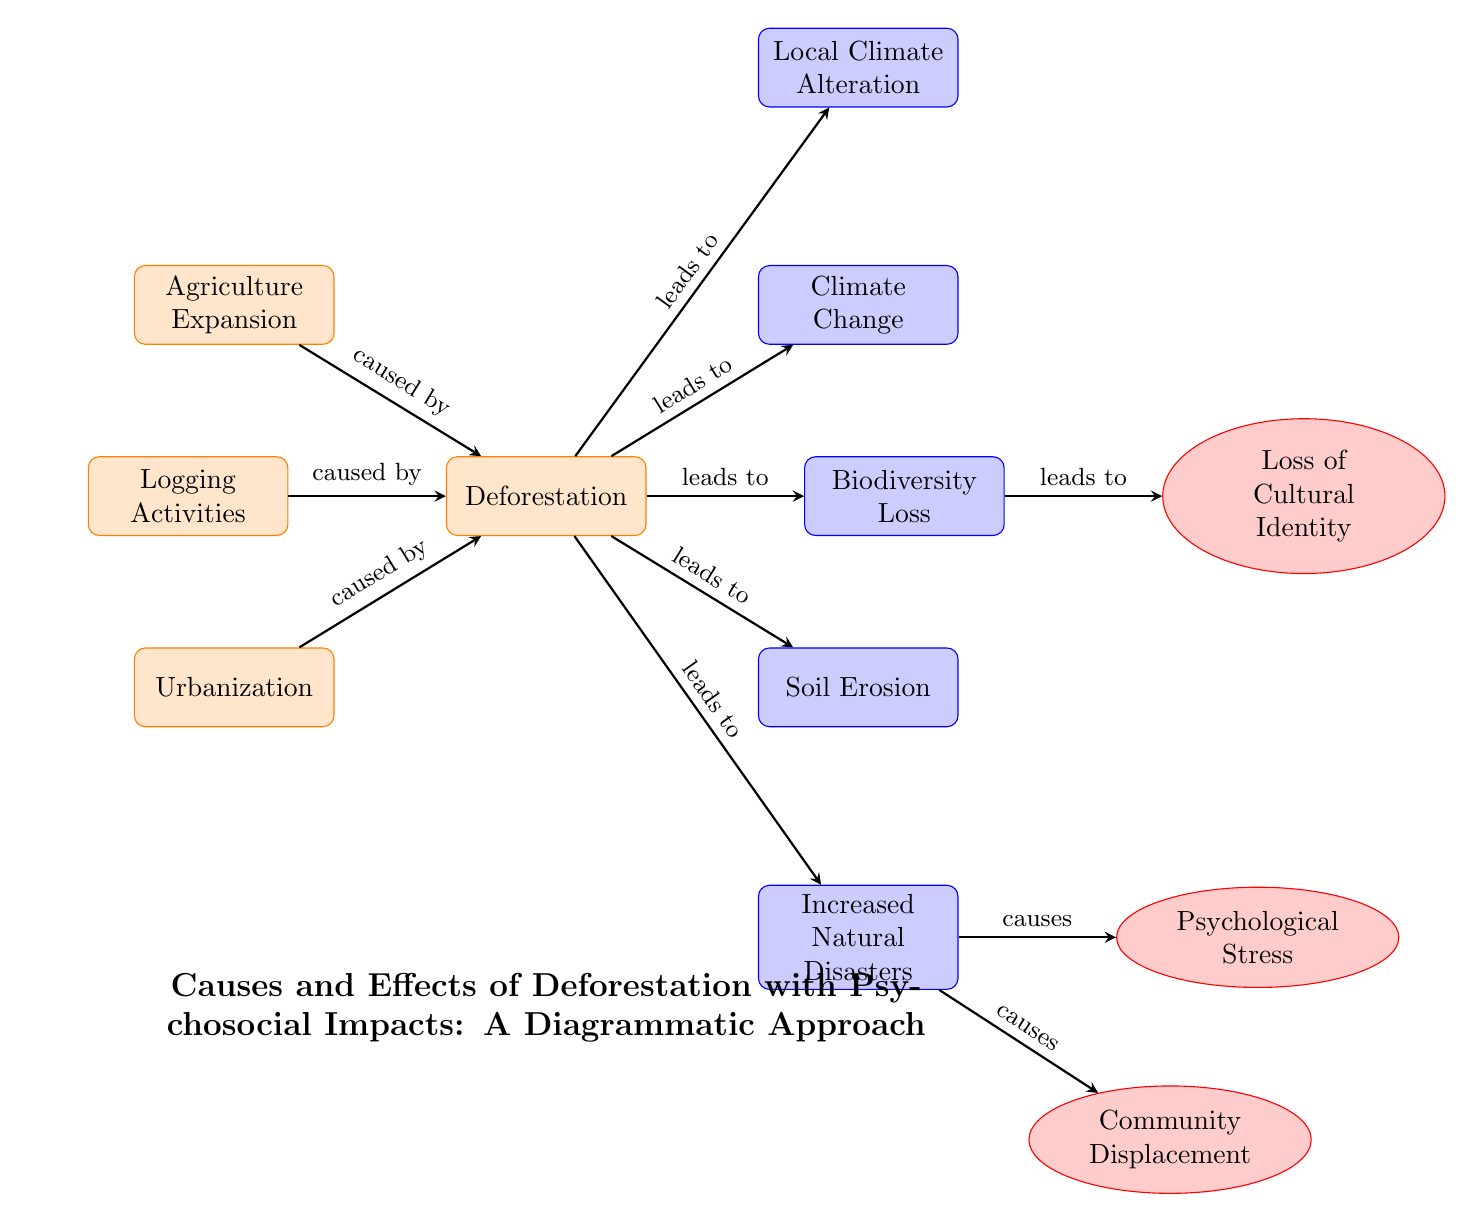What is the main topic of the diagram? The title at the bottom of the diagram clearly states that it is about the "Causes and Effects of Deforestation with Psychosocial Impacts."
Answer: Causes and Effects of Deforestation with Psychosocial Impacts How many causes of deforestation are depicted? There are three causes shown: Agriculture Expansion, Logging Activities, and Urbanization. Counting these nodes confirms the total.
Answer: 3 What effect follows directly from deforestation linked to climate? The diagram shows that deforestation leads to Climate Change, indicated by the direct arrow from deforestation to climate.
Answer: Climate Change Which psychosocial impact is linked to increased natural disasters? According to the diagram, Psychological Stress is linked to Increased Natural Disasters, as shown by the arrow indicating causation.
Answer: Psychological Stress What is the relationship between Biodiversity Loss and Loss of Cultural Identity? Biodiversity Loss leads to Loss of Cultural Identity, as evidenced by the arrow pointing from biodiversity to cultural identity in the diagram.
Answer: leads to What is a consequence of community displacement as per the diagram? While community displacement is shown in the diagram, its direct consequence, in terms of psychosocial impact, is not specified. However, it suggests relocation stress.
Answer: Not specified How many effects are listed as resulting from deforestation? There are five effects depicted as consequences of deforestation: Climate Change, Biodiversity Loss, Soil Erosion, Local Climate Alteration, and Increased Natural Disasters.
Answer: 5 Which causes are presented as leading to deforestation? The arrows show that Agriculture Expansion, Logging Activities, and Urbanization all lead to deforestation, highlighting three primary influences.
Answer: Agriculture Expansion, Logging Activities, Urbanization What is the direct psychological impact linked to biodiversity loss? The direct psychological impact linked to biodiversity loss is Loss of Cultural Identity, which is shown by the arrow leading from biodiversity to cultural identity.
Answer: Loss of Cultural Identity 